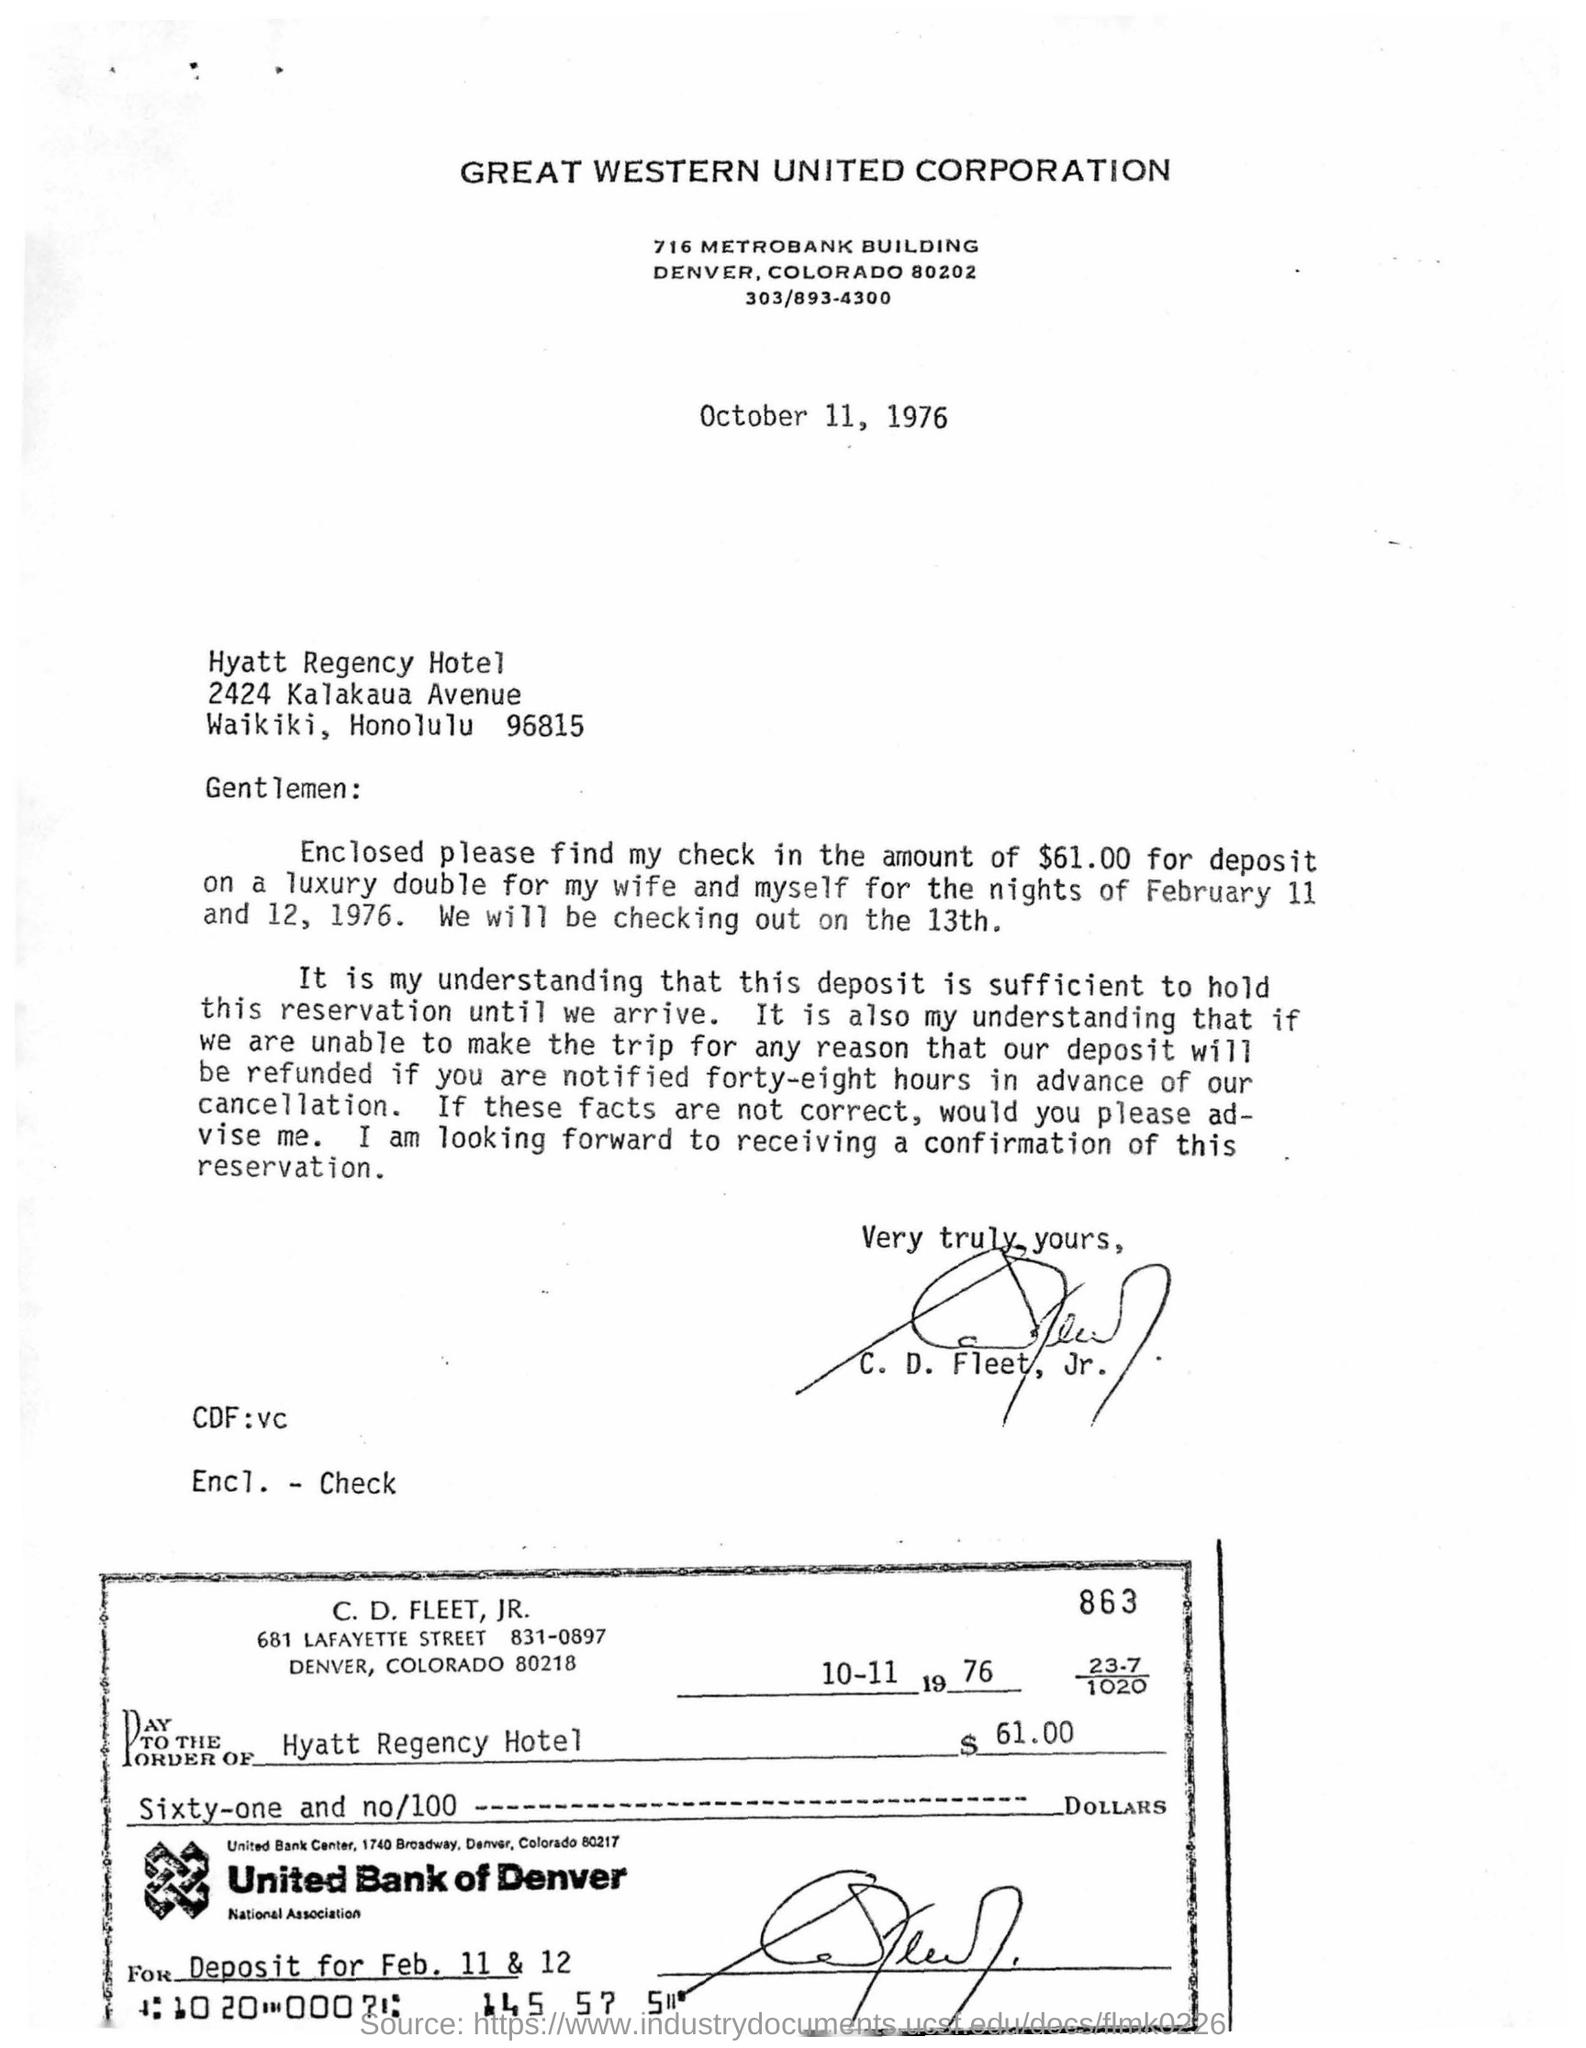Highlight a few significant elements in this photo. The check is from United Bank of Denver. The signature in the letter is that of C. D. Fleet, Jr. The amount deposited for a room in a hotel by CD Fleet is $61.00. Great Western United Corporation" is a corporation. The date mentioned on the check is 10th November 1976. 